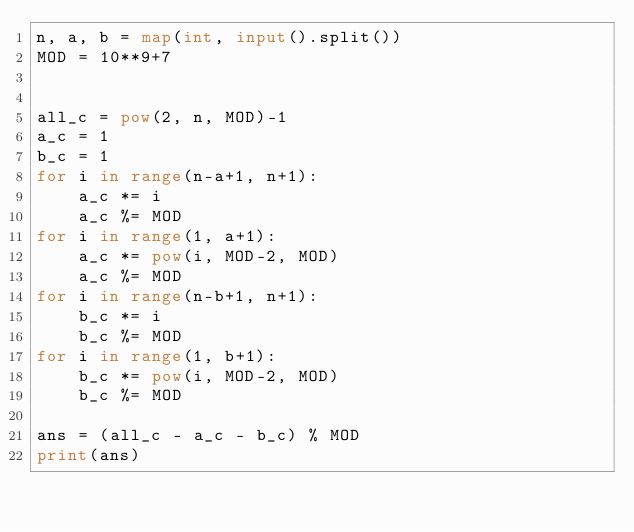<code> <loc_0><loc_0><loc_500><loc_500><_Python_>n, a, b = map(int, input().split())
MOD = 10**9+7


all_c = pow(2, n, MOD)-1
a_c = 1
b_c = 1
for i in range(n-a+1, n+1):
    a_c *= i
    a_c %= MOD
for i in range(1, a+1):
    a_c *= pow(i, MOD-2, MOD)
    a_c %= MOD
for i in range(n-b+1, n+1):
    b_c *= i
    b_c %= MOD
for i in range(1, b+1):
    b_c *= pow(i, MOD-2, MOD)
    b_c %= MOD

ans = (all_c - a_c - b_c) % MOD
print(ans)
</code> 